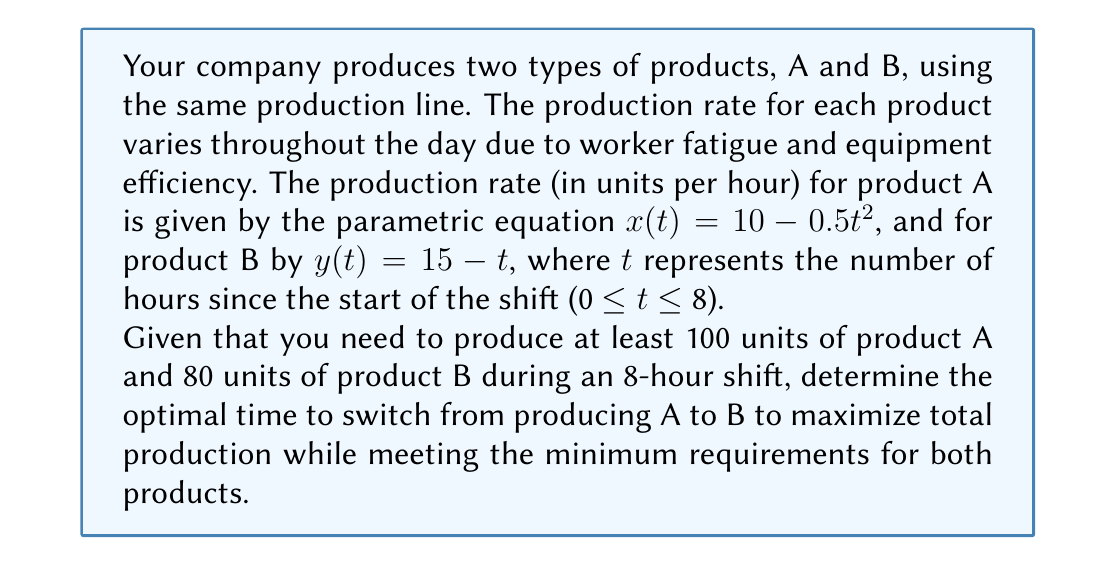Provide a solution to this math problem. To solve this optimization problem, we'll follow these steps:

1) First, let's calculate the total production of A and B as functions of the switch time $s$:

   For product A: $\int_0^s (10 - 0.5t^2) dt$
   For product B: $\int_s^8 (15 - t) dt$

2) Evaluate these integrals:

   Product A: $\int_0^s (10 - 0.5t^2) dt = [10t - \frac{1}{6}t^3]_0^s = 10s - \frac{1}{6}s^3$

   Product B: $\int_s^8 (15 - t) dt = [15t - \frac{1}{2}t^2]_s^8 = (120 - 32) - (15s - \frac{1}{2}s^2) = 88 - 15s + \frac{1}{2}s^2$

3) Set up constraints based on minimum production requirements:

   Product A: $10s - \frac{1}{6}s^3 \geq 100$
   Product B: $88 - 15s + \frac{1}{2}s^2 \geq 80$

4) The total production function to maximize is:

   $P(s) = (10s - \frac{1}{6}s^3) + (88 - 15s + \frac{1}{2}s^2) = 88 - 5s + \frac{1}{2}s^2 - \frac{1}{6}s^3$

5) To find the maximum, differentiate $P(s)$ and set it to zero:

   $P'(s) = -5 + s - \frac{1}{2}s^2 = 0$

6) Solve this quadratic equation:

   $\frac{1}{2}s^2 - s + 5 = 0$
   $s = \frac{1 \pm \sqrt{1 - 4(0.5)(5)}}{1} = \frac{1 \pm \sqrt{-9}}{1}$

   This has no real solutions, meaning there's no interior maximum.

7) Check the endpoints and the values that satisfy the constraints:

   At $s = 0$: Doesn't meet product A constraint
   At $s = 8$: Doesn't meet product B constraint

   Solve $10s - \frac{1}{6}s^3 = 100$ numerically to get $s \approx 5.77$ hours

8) Verify this satisfies the product B constraint:

   $88 - 15(5.77) + \frac{1}{2}(5.77)^2 \approx 80.02 > 80$

Therefore, the optimal switch time is approximately 5.77 hours.
Answer: The optimal time to switch from producing product A to product B is approximately 5.77 hours into the 8-hour shift. 